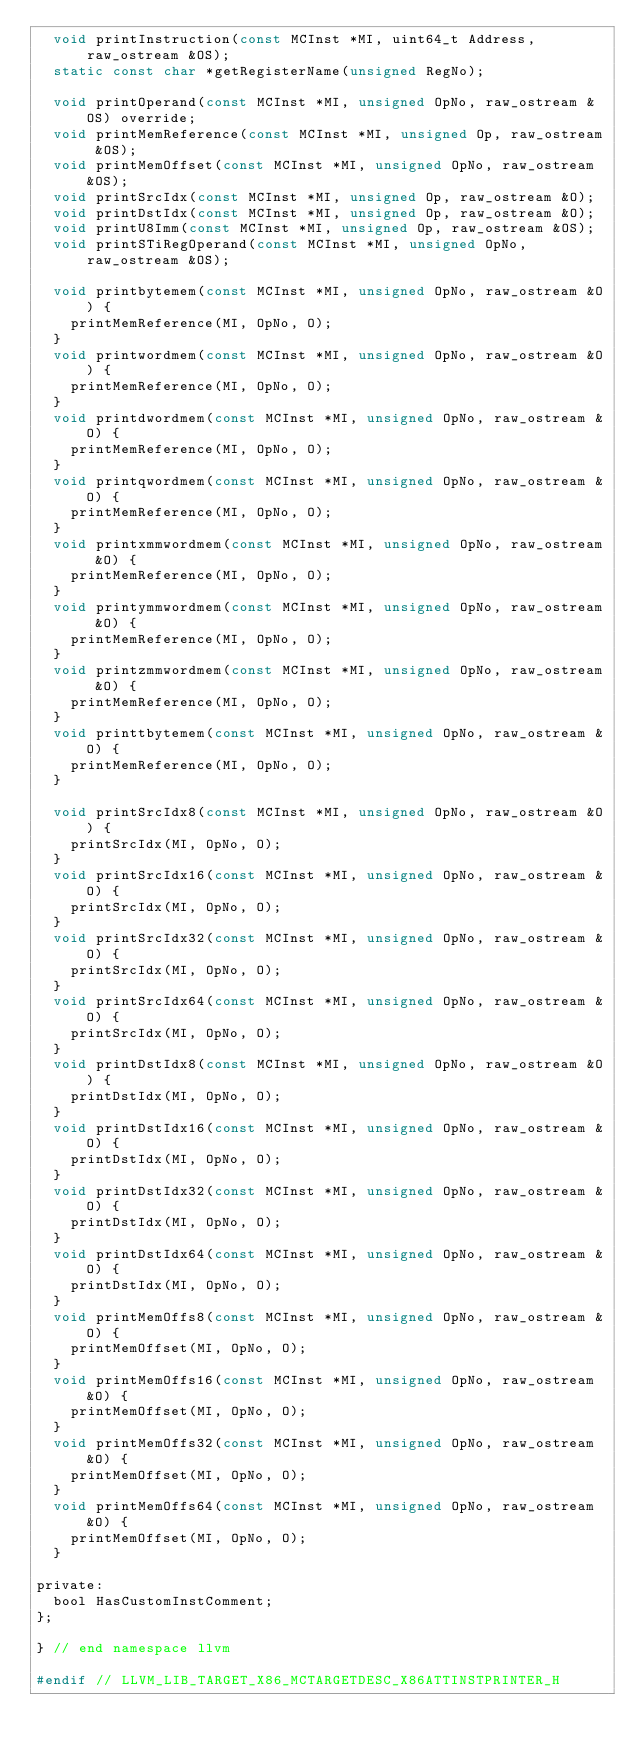Convert code to text. <code><loc_0><loc_0><loc_500><loc_500><_C_>  void printInstruction(const MCInst *MI, uint64_t Address, raw_ostream &OS);
  static const char *getRegisterName(unsigned RegNo);

  void printOperand(const MCInst *MI, unsigned OpNo, raw_ostream &OS) override;
  void printMemReference(const MCInst *MI, unsigned Op, raw_ostream &OS);
  void printMemOffset(const MCInst *MI, unsigned OpNo, raw_ostream &OS);
  void printSrcIdx(const MCInst *MI, unsigned Op, raw_ostream &O);
  void printDstIdx(const MCInst *MI, unsigned Op, raw_ostream &O);
  void printU8Imm(const MCInst *MI, unsigned Op, raw_ostream &OS);
  void printSTiRegOperand(const MCInst *MI, unsigned OpNo, raw_ostream &OS);

  void printbytemem(const MCInst *MI, unsigned OpNo, raw_ostream &O) {
    printMemReference(MI, OpNo, O);
  }
  void printwordmem(const MCInst *MI, unsigned OpNo, raw_ostream &O) {
    printMemReference(MI, OpNo, O);
  }
  void printdwordmem(const MCInst *MI, unsigned OpNo, raw_ostream &O) {
    printMemReference(MI, OpNo, O);
  }
  void printqwordmem(const MCInst *MI, unsigned OpNo, raw_ostream &O) {
    printMemReference(MI, OpNo, O);
  }
  void printxmmwordmem(const MCInst *MI, unsigned OpNo, raw_ostream &O) {
    printMemReference(MI, OpNo, O);
  }
  void printymmwordmem(const MCInst *MI, unsigned OpNo, raw_ostream &O) {
    printMemReference(MI, OpNo, O);
  }
  void printzmmwordmem(const MCInst *MI, unsigned OpNo, raw_ostream &O) {
    printMemReference(MI, OpNo, O);
  }
  void printtbytemem(const MCInst *MI, unsigned OpNo, raw_ostream &O) {
    printMemReference(MI, OpNo, O);
  }

  void printSrcIdx8(const MCInst *MI, unsigned OpNo, raw_ostream &O) {
    printSrcIdx(MI, OpNo, O);
  }
  void printSrcIdx16(const MCInst *MI, unsigned OpNo, raw_ostream &O) {
    printSrcIdx(MI, OpNo, O);
  }
  void printSrcIdx32(const MCInst *MI, unsigned OpNo, raw_ostream &O) {
    printSrcIdx(MI, OpNo, O);
  }
  void printSrcIdx64(const MCInst *MI, unsigned OpNo, raw_ostream &O) {
    printSrcIdx(MI, OpNo, O);
  }
  void printDstIdx8(const MCInst *MI, unsigned OpNo, raw_ostream &O) {
    printDstIdx(MI, OpNo, O);
  }
  void printDstIdx16(const MCInst *MI, unsigned OpNo, raw_ostream &O) {
    printDstIdx(MI, OpNo, O);
  }
  void printDstIdx32(const MCInst *MI, unsigned OpNo, raw_ostream &O) {
    printDstIdx(MI, OpNo, O);
  }
  void printDstIdx64(const MCInst *MI, unsigned OpNo, raw_ostream &O) {
    printDstIdx(MI, OpNo, O);
  }
  void printMemOffs8(const MCInst *MI, unsigned OpNo, raw_ostream &O) {
    printMemOffset(MI, OpNo, O);
  }
  void printMemOffs16(const MCInst *MI, unsigned OpNo, raw_ostream &O) {
    printMemOffset(MI, OpNo, O);
  }
  void printMemOffs32(const MCInst *MI, unsigned OpNo, raw_ostream &O) {
    printMemOffset(MI, OpNo, O);
  }
  void printMemOffs64(const MCInst *MI, unsigned OpNo, raw_ostream &O) {
    printMemOffset(MI, OpNo, O);
  }

private:
  bool HasCustomInstComment;
};

} // end namespace llvm

#endif // LLVM_LIB_TARGET_X86_MCTARGETDESC_X86ATTINSTPRINTER_H
</code> 